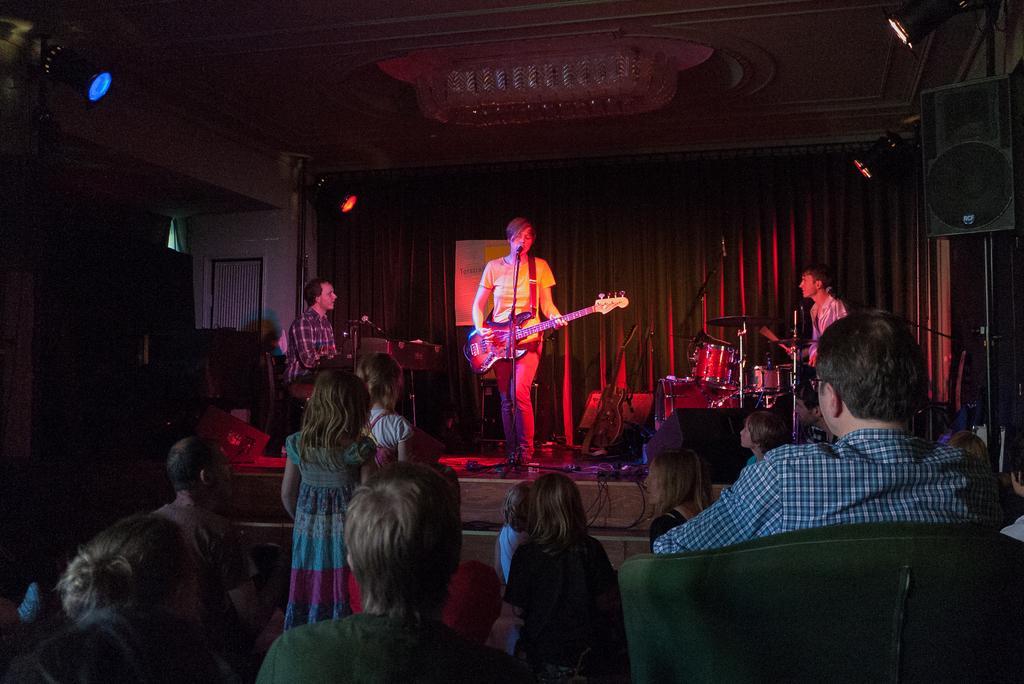Describe this image in one or two sentences. In this image there are group of people. The man is standing and holding a guitar. 